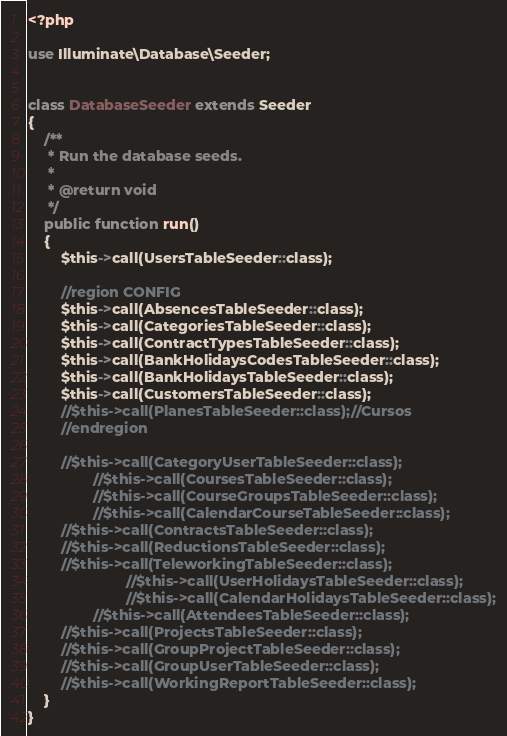Convert code to text. <code><loc_0><loc_0><loc_500><loc_500><_PHP_><?php

use Illuminate\Database\Seeder;


class DatabaseSeeder extends Seeder
{
    /**
     * Run the database seeds.
     *
     * @return void
     */
    public function run()
    {
        $this->call(UsersTableSeeder::class);

        //region CONFIG
        $this->call(AbsencesTableSeeder::class);
        $this->call(CategoriesTableSeeder::class);
        $this->call(ContractTypesTableSeeder::class);
        $this->call(BankHolidaysCodesTableSeeder::class);
        $this->call(BankHolidaysTableSeeder::class);
        $this->call(CustomersTableSeeder::class);
        //$this->call(PlanesTableSeeder::class);//Cursos
        //endregion

        //$this->call(CategoryUserTableSeeder::class);
                //$this->call(CoursesTableSeeder::class);
                //$this->call(CourseGroupsTableSeeder::class);
                //$this->call(CalendarCourseTableSeeder::class);    
        //$this->call(ContractsTableSeeder::class);
        //$this->call(ReductionsTableSeeder::class);
        //$this->call(TeleworkingTableSeeder::class);
                        //$this->call(UserHolidaysTableSeeder::class);
                        //$this->call(CalendarHolidaysTableSeeder::class);
                //$this->call(AttendeesTableSeeder::class);
        //$this->call(ProjectsTableSeeder::class);  
        //$this->call(GroupProjectTableSeeder::class); 
        //$this->call(GroupUserTableSeeder::class);
        //$this->call(WorkingReportTableSeeder::class); 
    }
}
</code> 